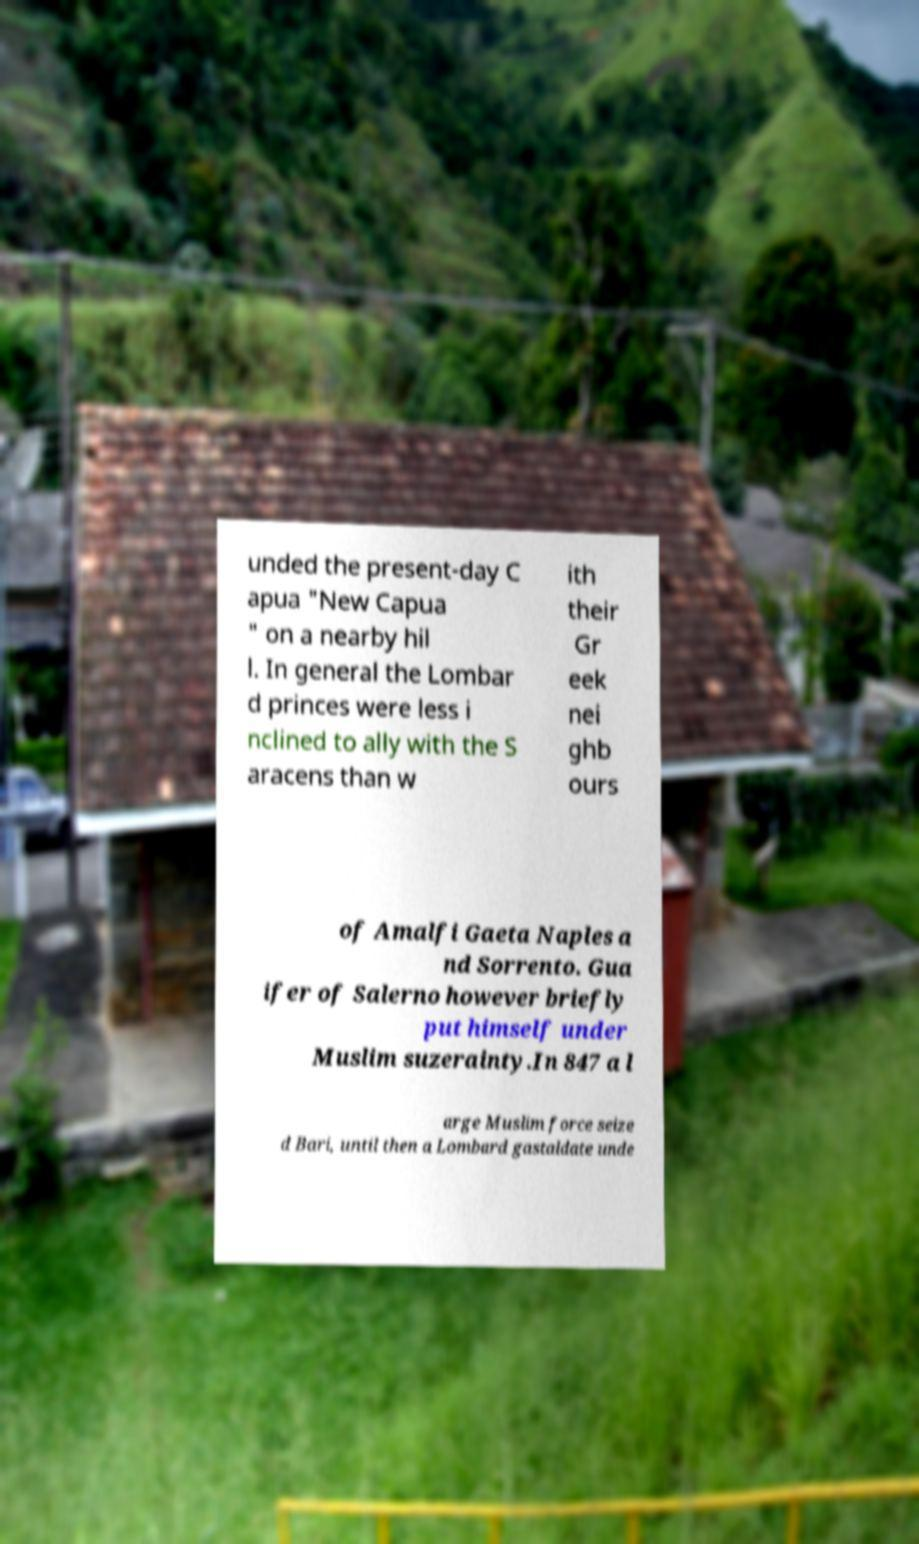I need the written content from this picture converted into text. Can you do that? unded the present-day C apua "New Capua " on a nearby hil l. In general the Lombar d princes were less i nclined to ally with the S aracens than w ith their Gr eek nei ghb ours of Amalfi Gaeta Naples a nd Sorrento. Gua ifer of Salerno however briefly put himself under Muslim suzerainty.In 847 a l arge Muslim force seize d Bari, until then a Lombard gastaldate unde 